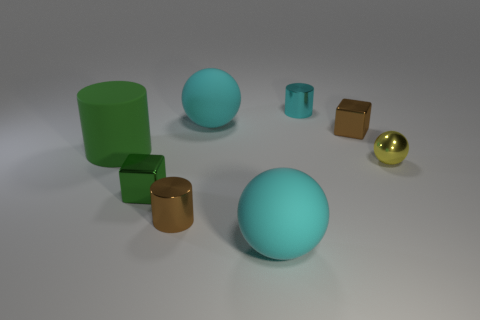How big is the cyan object that is to the left of the matte sphere in front of the brown metallic cube?
Ensure brevity in your answer.  Large. What color is the tiny cylinder that is in front of the small cyan thing?
Offer a terse response. Brown. There is a cyan cylinder that is the same material as the brown cylinder; what size is it?
Provide a short and direct response. Small. What number of tiny brown things have the same shape as the small yellow shiny thing?
Provide a short and direct response. 0. What is the material of the brown block that is the same size as the metallic ball?
Keep it short and to the point. Metal. Is there a cyan thing made of the same material as the cyan cylinder?
Provide a succinct answer. No. The sphere that is on the left side of the tiny brown metallic block and behind the brown shiny cylinder is what color?
Provide a short and direct response. Cyan. What number of other objects are there of the same color as the tiny sphere?
Your answer should be compact. 0. What is the material of the cube on the right side of the big cyan rubber ball that is in front of the rubber ball behind the yellow shiny thing?
Provide a succinct answer. Metal. What number of blocks are cyan metallic objects or big cyan objects?
Your answer should be very brief. 0. 